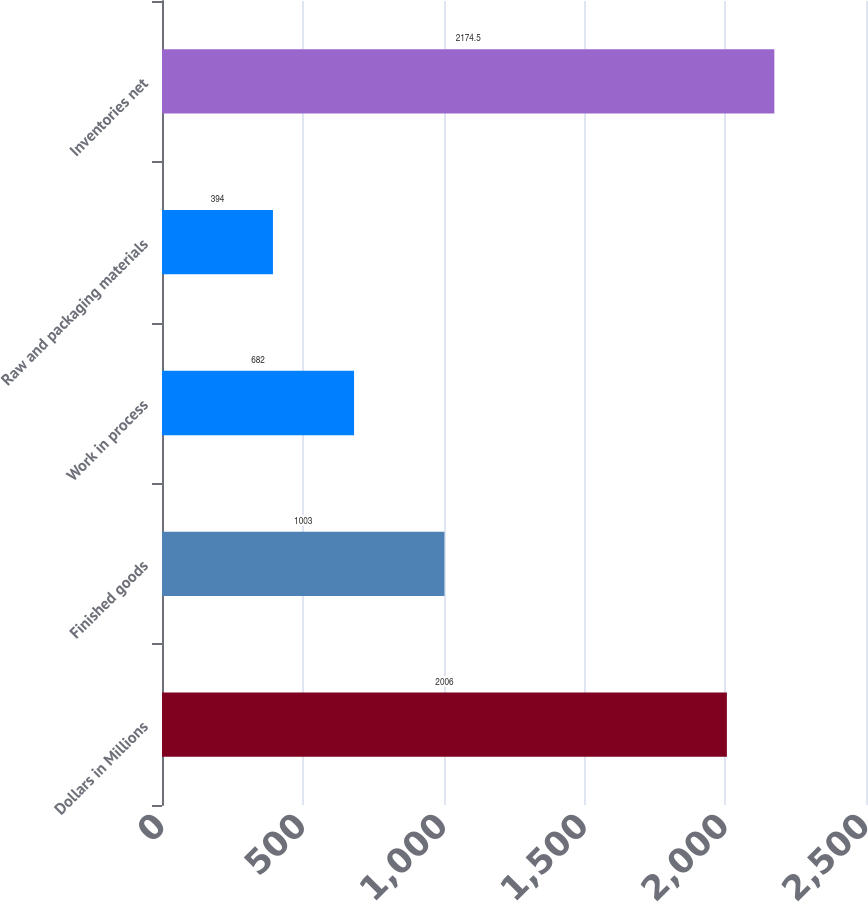<chart> <loc_0><loc_0><loc_500><loc_500><bar_chart><fcel>Dollars in Millions<fcel>Finished goods<fcel>Work in process<fcel>Raw and packaging materials<fcel>Inventories net<nl><fcel>2006<fcel>1003<fcel>682<fcel>394<fcel>2174.5<nl></chart> 